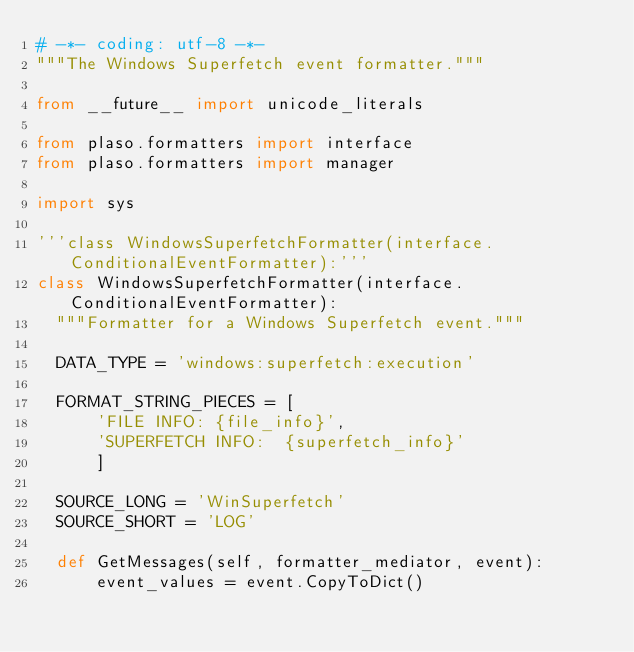Convert code to text. <code><loc_0><loc_0><loc_500><loc_500><_Python_># -*- coding: utf-8 -*-
"""The Windows Superfetch event formatter."""

from __future__ import unicode_literals

from plaso.formatters import interface
from plaso.formatters import manager

import sys

'''class WindowsSuperfetchFormatter(interface.ConditionalEventFormatter):'''
class WindowsSuperfetchFormatter(interface.ConditionalEventFormatter):
  """Formatter for a Windows Superfetch event."""

  DATA_TYPE = 'windows:superfetch:execution'

  FORMAT_STRING_PIECES = [
      'FILE INFO: {file_info}',
      'SUPERFETCH INFO:  {superfetch_info}'
      ]

  SOURCE_LONG = 'WinSuperfetch'
  SOURCE_SHORT = 'LOG'

  def GetMessages(self, formatter_mediator, event):
      event_values = event.CopyToDict()</code> 